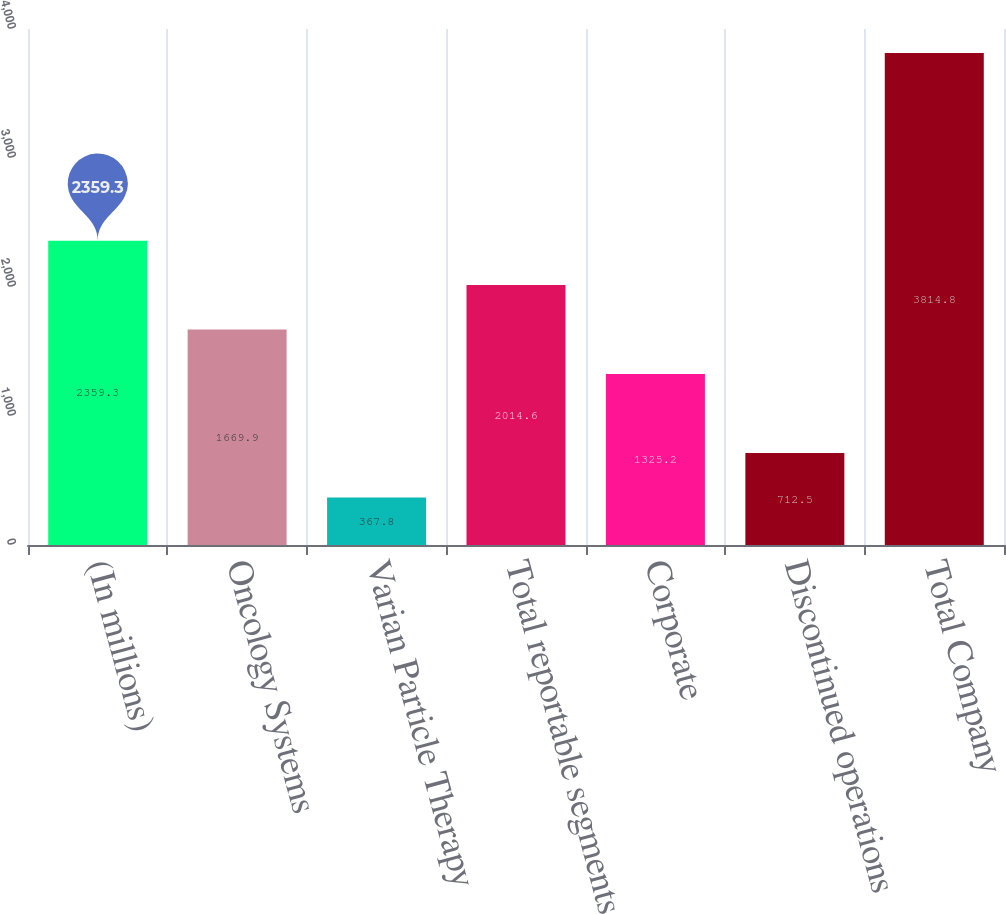Convert chart to OTSL. <chart><loc_0><loc_0><loc_500><loc_500><bar_chart><fcel>(In millions)<fcel>Oncology Systems<fcel>Varian Particle Therapy<fcel>Total reportable segments<fcel>Corporate<fcel>Discontinued operations<fcel>Total Company<nl><fcel>2359.3<fcel>1669.9<fcel>367.8<fcel>2014.6<fcel>1325.2<fcel>712.5<fcel>3814.8<nl></chart> 